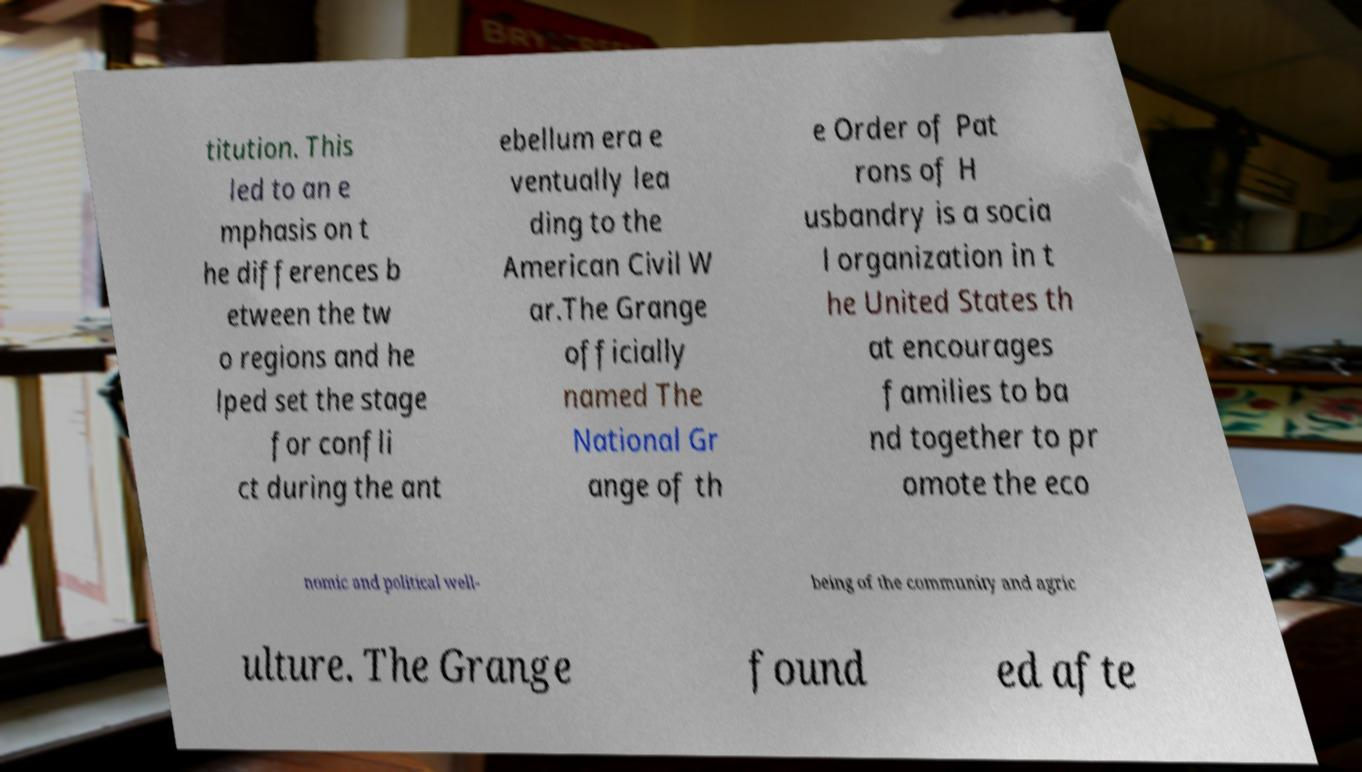I need the written content from this picture converted into text. Can you do that? titution. This led to an e mphasis on t he differences b etween the tw o regions and he lped set the stage for confli ct during the ant ebellum era e ventually lea ding to the American Civil W ar.The Grange officially named The National Gr ange of th e Order of Pat rons of H usbandry is a socia l organization in t he United States th at encourages families to ba nd together to pr omote the eco nomic and political well- being of the community and agric ulture. The Grange found ed afte 